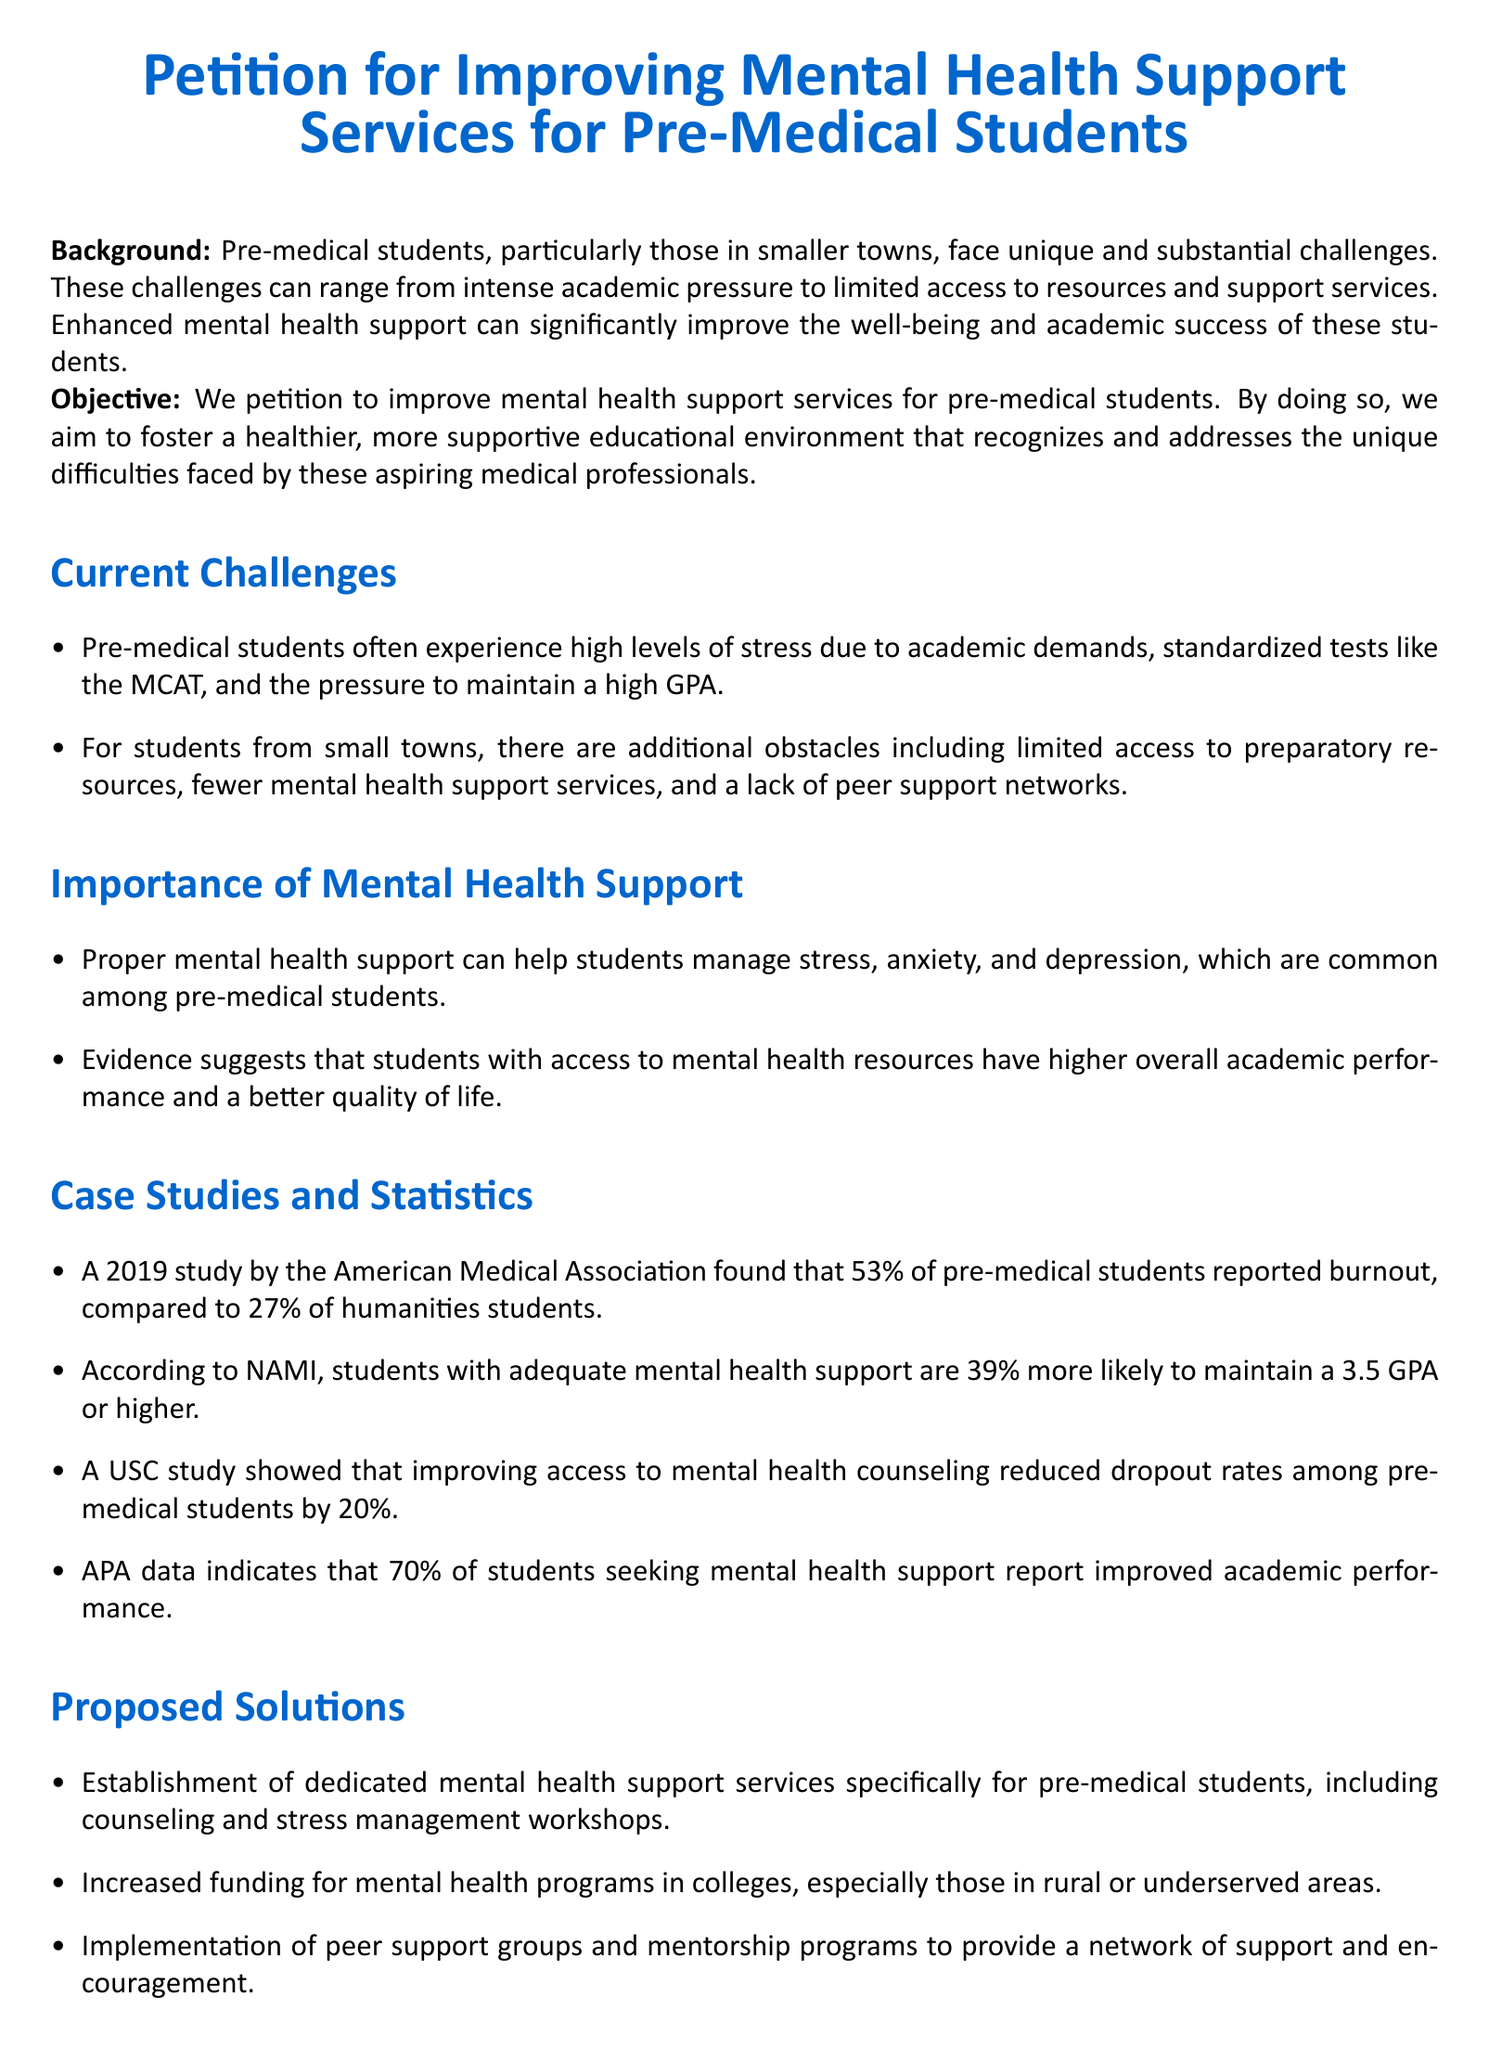What is the title of the petition? The title of the petition is clearly stated at the top of the document.
Answer: Petition for Improving Mental Health Support Services for Pre-Medical Students What percentage of pre-medical students reported burnout according to the 2019 study? The percentage of pre-medical students reporting burnout is mentioned alongside statistics in the document.
Answer: 53% What impact does proper mental health support have on academic performance according to the American Psychological Association data? The document cites statistics from the APA regarding students seeking mental health support.
Answer: Improved academic performance What is one proposed solution for improving mental health support? The document lists several proposed solutions, making it easy to extract specific suggestions.
Answer: Establishment of dedicated mental health support services What is the percentage increase in the likelihood of maintaining a 3.5 GPA or higher with mental health support? This statistic is provided in the importance section, linking mental health to academic success.
Answer: 39% What is the call to action in the petition? The call to action summarizes the purpose of the petition clearly in a highlighted section.
Answer: Improve mental health support for pre-medical students 